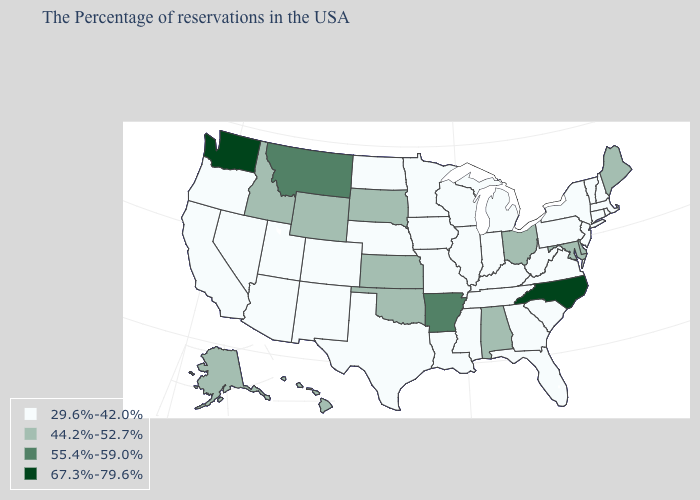Does the first symbol in the legend represent the smallest category?
Give a very brief answer. Yes. Name the states that have a value in the range 29.6%-42.0%?
Keep it brief. Massachusetts, Rhode Island, New Hampshire, Vermont, Connecticut, New York, New Jersey, Pennsylvania, Virginia, South Carolina, West Virginia, Florida, Georgia, Michigan, Kentucky, Indiana, Tennessee, Wisconsin, Illinois, Mississippi, Louisiana, Missouri, Minnesota, Iowa, Nebraska, Texas, North Dakota, Colorado, New Mexico, Utah, Arizona, Nevada, California, Oregon. Among the states that border Alabama , which have the highest value?
Write a very short answer. Florida, Georgia, Tennessee, Mississippi. Is the legend a continuous bar?
Give a very brief answer. No. Among the states that border New Hampshire , does Maine have the lowest value?
Keep it brief. No. Name the states that have a value in the range 29.6%-42.0%?
Give a very brief answer. Massachusetts, Rhode Island, New Hampshire, Vermont, Connecticut, New York, New Jersey, Pennsylvania, Virginia, South Carolina, West Virginia, Florida, Georgia, Michigan, Kentucky, Indiana, Tennessee, Wisconsin, Illinois, Mississippi, Louisiana, Missouri, Minnesota, Iowa, Nebraska, Texas, North Dakota, Colorado, New Mexico, Utah, Arizona, Nevada, California, Oregon. Does Washington have the highest value in the West?
Quick response, please. Yes. What is the value of Arkansas?
Concise answer only. 55.4%-59.0%. What is the value of North Dakota?
Concise answer only. 29.6%-42.0%. What is the value of Illinois?
Short answer required. 29.6%-42.0%. Which states have the lowest value in the USA?
Quick response, please. Massachusetts, Rhode Island, New Hampshire, Vermont, Connecticut, New York, New Jersey, Pennsylvania, Virginia, South Carolina, West Virginia, Florida, Georgia, Michigan, Kentucky, Indiana, Tennessee, Wisconsin, Illinois, Mississippi, Louisiana, Missouri, Minnesota, Iowa, Nebraska, Texas, North Dakota, Colorado, New Mexico, Utah, Arizona, Nevada, California, Oregon. What is the highest value in the USA?
Short answer required. 67.3%-79.6%. 